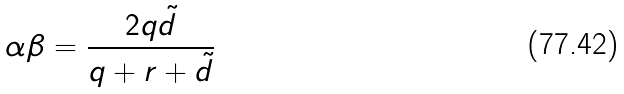Convert formula to latex. <formula><loc_0><loc_0><loc_500><loc_500>\alpha \beta = \frac { 2 q { \tilde { d } } } { q + r + { \tilde { d } } }</formula> 